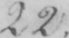Can you tell me what this handwritten text says? 22 . 